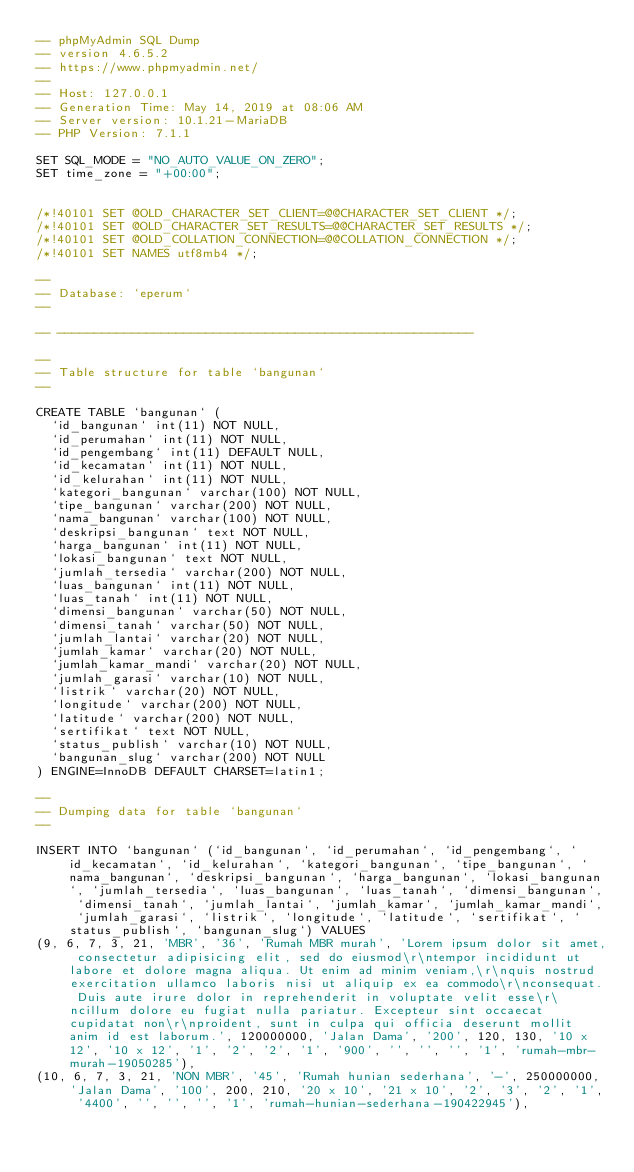<code> <loc_0><loc_0><loc_500><loc_500><_SQL_>-- phpMyAdmin SQL Dump
-- version 4.6.5.2
-- https://www.phpmyadmin.net/
--
-- Host: 127.0.0.1
-- Generation Time: May 14, 2019 at 08:06 AM
-- Server version: 10.1.21-MariaDB
-- PHP Version: 7.1.1

SET SQL_MODE = "NO_AUTO_VALUE_ON_ZERO";
SET time_zone = "+00:00";


/*!40101 SET @OLD_CHARACTER_SET_CLIENT=@@CHARACTER_SET_CLIENT */;
/*!40101 SET @OLD_CHARACTER_SET_RESULTS=@@CHARACTER_SET_RESULTS */;
/*!40101 SET @OLD_COLLATION_CONNECTION=@@COLLATION_CONNECTION */;
/*!40101 SET NAMES utf8mb4 */;

--
-- Database: `eperum`
--

-- --------------------------------------------------------

--
-- Table structure for table `bangunan`
--

CREATE TABLE `bangunan` (
  `id_bangunan` int(11) NOT NULL,
  `id_perumahan` int(11) NOT NULL,
  `id_pengembang` int(11) DEFAULT NULL,
  `id_kecamatan` int(11) NOT NULL,
  `id_kelurahan` int(11) NOT NULL,
  `kategori_bangunan` varchar(100) NOT NULL,
  `tipe_bangunan` varchar(200) NOT NULL,
  `nama_bangunan` varchar(100) NOT NULL,
  `deskripsi_bangunan` text NOT NULL,
  `harga_bangunan` int(11) NOT NULL,
  `lokasi_bangunan` text NOT NULL,
  `jumlah_tersedia` varchar(200) NOT NULL,
  `luas_bangunan` int(11) NOT NULL,
  `luas_tanah` int(11) NOT NULL,
  `dimensi_bangunan` varchar(50) NOT NULL,
  `dimensi_tanah` varchar(50) NOT NULL,
  `jumlah_lantai` varchar(20) NOT NULL,
  `jumlah_kamar` varchar(20) NOT NULL,
  `jumlah_kamar_mandi` varchar(20) NOT NULL,
  `jumlah_garasi` varchar(10) NOT NULL,
  `listrik` varchar(20) NOT NULL,
  `longitude` varchar(200) NOT NULL,
  `latitude` varchar(200) NOT NULL,
  `sertifikat` text NOT NULL,
  `status_publish` varchar(10) NOT NULL,
  `bangunan_slug` varchar(200) NOT NULL
) ENGINE=InnoDB DEFAULT CHARSET=latin1;

--
-- Dumping data for table `bangunan`
--

INSERT INTO `bangunan` (`id_bangunan`, `id_perumahan`, `id_pengembang`, `id_kecamatan`, `id_kelurahan`, `kategori_bangunan`, `tipe_bangunan`, `nama_bangunan`, `deskripsi_bangunan`, `harga_bangunan`, `lokasi_bangunan`, `jumlah_tersedia`, `luas_bangunan`, `luas_tanah`, `dimensi_bangunan`, `dimensi_tanah`, `jumlah_lantai`, `jumlah_kamar`, `jumlah_kamar_mandi`, `jumlah_garasi`, `listrik`, `longitude`, `latitude`, `sertifikat`, `status_publish`, `bangunan_slug`) VALUES
(9, 6, 7, 3, 21, 'MBR', '36', 'Rumah MBR murah', 'Lorem ipsum dolor sit amet, consectetur adipisicing elit, sed do eiusmod\r\ntempor incididunt ut labore et dolore magna aliqua. Ut enim ad minim veniam,\r\nquis nostrud exercitation ullamco laboris nisi ut aliquip ex ea commodo\r\nconsequat. Duis aute irure dolor in reprehenderit in voluptate velit esse\r\ncillum dolore eu fugiat nulla pariatur. Excepteur sint occaecat cupidatat non\r\nproident, sunt in culpa qui officia deserunt mollit anim id est laborum.', 120000000, 'Jalan Dama', '200', 120, 130, '10 x 12', '10 x 12', '1', '2', '2', '1', '900', '', '', '', '1', 'rumah-mbr-murah-19050285'),
(10, 6, 7, 3, 21, 'NON MBR', '45', 'Rumah hunian sederhana', '-', 250000000, 'Jalan Dama', '100', 200, 210, '20 x 10', '21 x 10', '2', '3', '2', '1', '4400', '', '', '', '1', 'rumah-hunian-sederhana-190422945'),</code> 